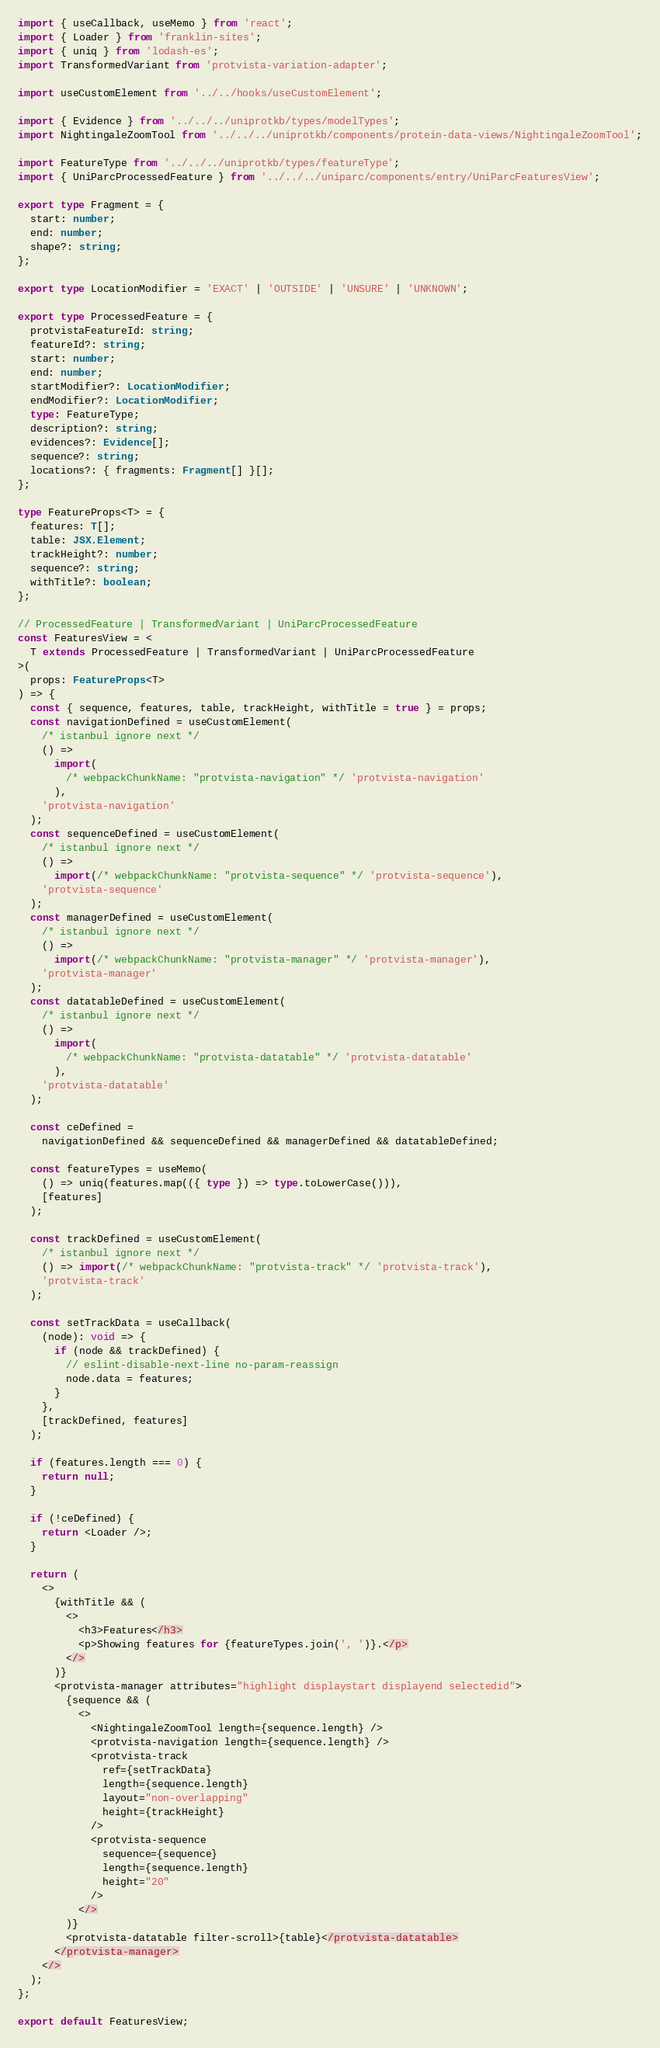Convert code to text. <code><loc_0><loc_0><loc_500><loc_500><_TypeScript_>import { useCallback, useMemo } from 'react';
import { Loader } from 'franklin-sites';
import { uniq } from 'lodash-es';
import TransformedVariant from 'protvista-variation-adapter';

import useCustomElement from '../../hooks/useCustomElement';

import { Evidence } from '../../../uniprotkb/types/modelTypes';
import NightingaleZoomTool from '../../../uniprotkb/components/protein-data-views/NightingaleZoomTool';

import FeatureType from '../../../uniprotkb/types/featureType';
import { UniParcProcessedFeature } from '../../../uniparc/components/entry/UniParcFeaturesView';

export type Fragment = {
  start: number;
  end: number;
  shape?: string;
};

export type LocationModifier = 'EXACT' | 'OUTSIDE' | 'UNSURE' | 'UNKNOWN';

export type ProcessedFeature = {
  protvistaFeatureId: string;
  featureId?: string;
  start: number;
  end: number;
  startModifier?: LocationModifier;
  endModifier?: LocationModifier;
  type: FeatureType;
  description?: string;
  evidences?: Evidence[];
  sequence?: string;
  locations?: { fragments: Fragment[] }[];
};

type FeatureProps<T> = {
  features: T[];
  table: JSX.Element;
  trackHeight?: number;
  sequence?: string;
  withTitle?: boolean;
};

// ProcessedFeature | TransformedVariant | UniParcProcessedFeature
const FeaturesView = <
  T extends ProcessedFeature | TransformedVariant | UniParcProcessedFeature
>(
  props: FeatureProps<T>
) => {
  const { sequence, features, table, trackHeight, withTitle = true } = props;
  const navigationDefined = useCustomElement(
    /* istanbul ignore next */
    () =>
      import(
        /* webpackChunkName: "protvista-navigation" */ 'protvista-navigation'
      ),
    'protvista-navigation'
  );
  const sequenceDefined = useCustomElement(
    /* istanbul ignore next */
    () =>
      import(/* webpackChunkName: "protvista-sequence" */ 'protvista-sequence'),
    'protvista-sequence'
  );
  const managerDefined = useCustomElement(
    /* istanbul ignore next */
    () =>
      import(/* webpackChunkName: "protvista-manager" */ 'protvista-manager'),
    'protvista-manager'
  );
  const datatableDefined = useCustomElement(
    /* istanbul ignore next */
    () =>
      import(
        /* webpackChunkName: "protvista-datatable" */ 'protvista-datatable'
      ),
    'protvista-datatable'
  );

  const ceDefined =
    navigationDefined && sequenceDefined && managerDefined && datatableDefined;

  const featureTypes = useMemo(
    () => uniq(features.map(({ type }) => type.toLowerCase())),
    [features]
  );

  const trackDefined = useCustomElement(
    /* istanbul ignore next */
    () => import(/* webpackChunkName: "protvista-track" */ 'protvista-track'),
    'protvista-track'
  );

  const setTrackData = useCallback(
    (node): void => {
      if (node && trackDefined) {
        // eslint-disable-next-line no-param-reassign
        node.data = features;
      }
    },
    [trackDefined, features]
  );

  if (features.length === 0) {
    return null;
  }

  if (!ceDefined) {
    return <Loader />;
  }

  return (
    <>
      {withTitle && (
        <>
          <h3>Features</h3>
          <p>Showing features for {featureTypes.join(', ')}.</p>
        </>
      )}
      <protvista-manager attributes="highlight displaystart displayend selectedid">
        {sequence && (
          <>
            <NightingaleZoomTool length={sequence.length} />
            <protvista-navigation length={sequence.length} />
            <protvista-track
              ref={setTrackData}
              length={sequence.length}
              layout="non-overlapping"
              height={trackHeight}
            />
            <protvista-sequence
              sequence={sequence}
              length={sequence.length}
              height="20"
            />
          </>
        )}
        <protvista-datatable filter-scroll>{table}</protvista-datatable>
      </protvista-manager>
    </>
  );
};

export default FeaturesView;
</code> 